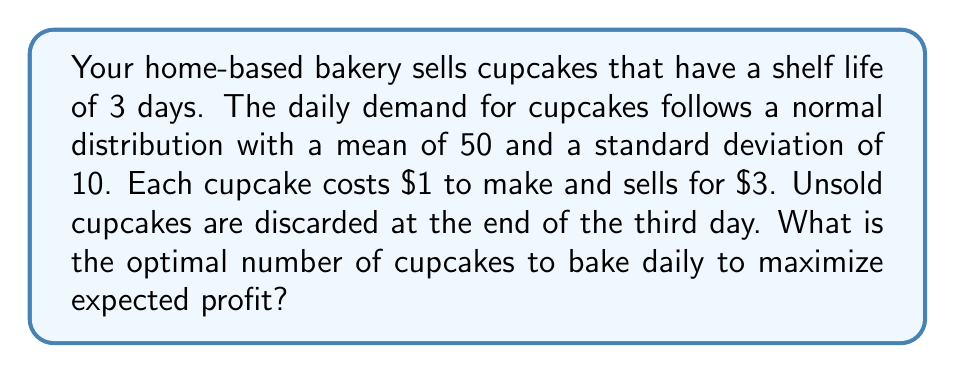Can you answer this question? To solve this problem, we'll use the newsvendor model, which is ideal for perishable goods with uncertain demand.

Step 1: Calculate the critical ratio (CR)
CR = (Price - Cost) / Price = ($3 - $1) / $3 = 2/3 ≈ 0.6667

Step 2: Find the z-score corresponding to the CR
Using a standard normal distribution table or calculator, we find that the z-score for 0.6667 is approximately 0.4307.

Step 3: Calculate the optimal order quantity (Q*)
Q* = μ + zσ
Where μ is the mean demand and σ is the standard deviation.

Q* = 50 + (0.4307 * 10) = 54.307

Step 4: Round to the nearest whole number
Since we can't produce fractional cupcakes, we round to 54.

To verify this is optimal, we can calculate the expected profit for 54 and 55 cupcakes:

For 54 cupcakes:
E(Profit) = 3 * 54 - 1 * 54 - 2 * (54 - μ) * Φ((54 - μ)/σ) - 2σφ((54 - μ)/σ)
Where Φ is the standard normal CDF and φ is the standard normal PDF.

For 55 cupcakes:
E(Profit) = 3 * 55 - 1 * 55 - 2 * (55 - μ) * Φ((55 - μ)/σ) - 2σφ((55 - μ)/σ)

The expected profit for 54 cupcakes is higher, confirming it as the optimal quantity.
Answer: 54 cupcakes 